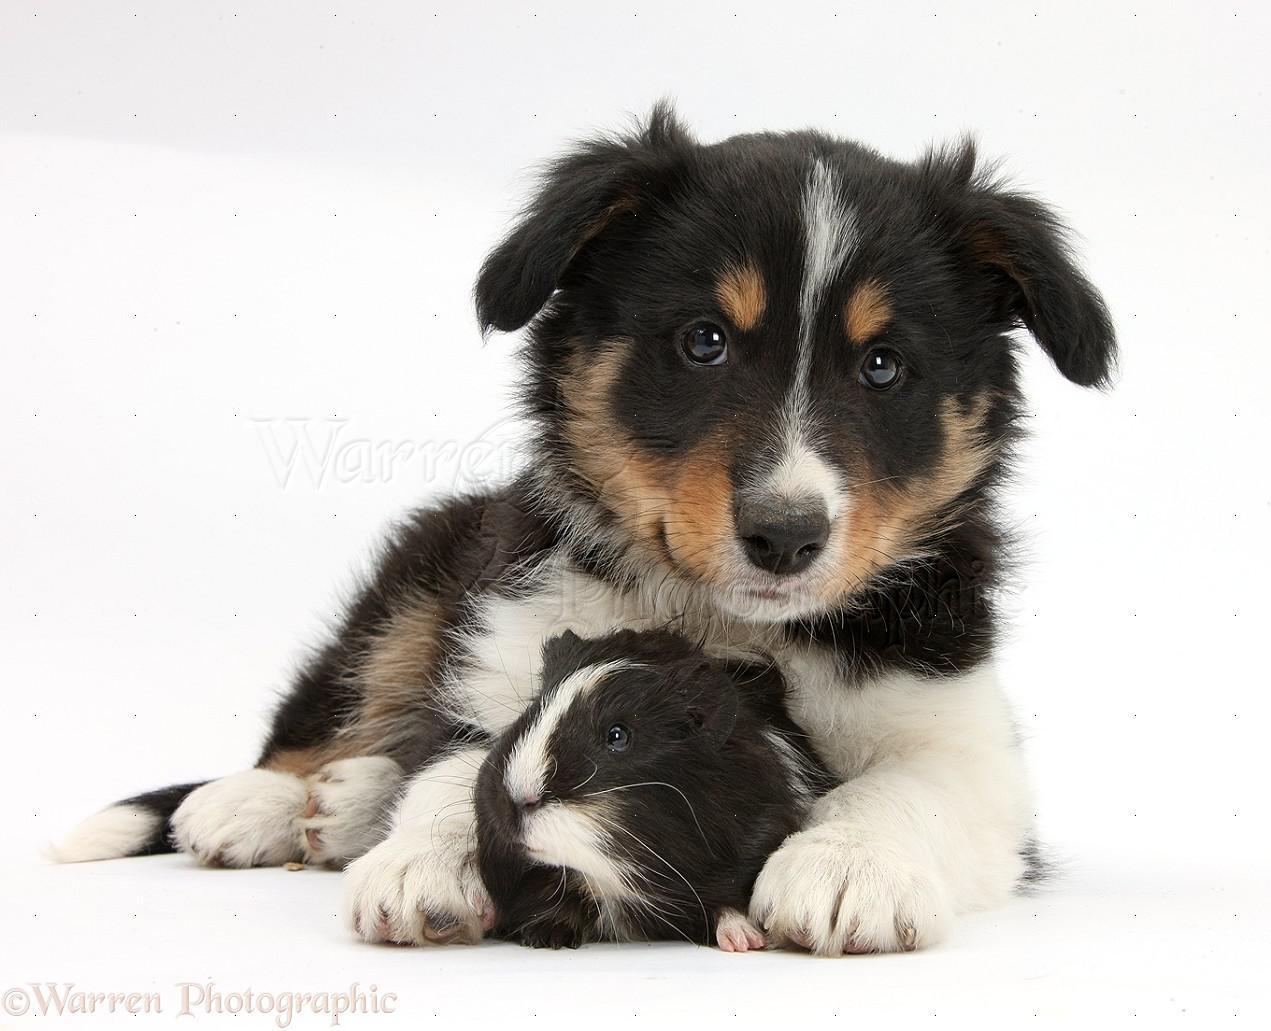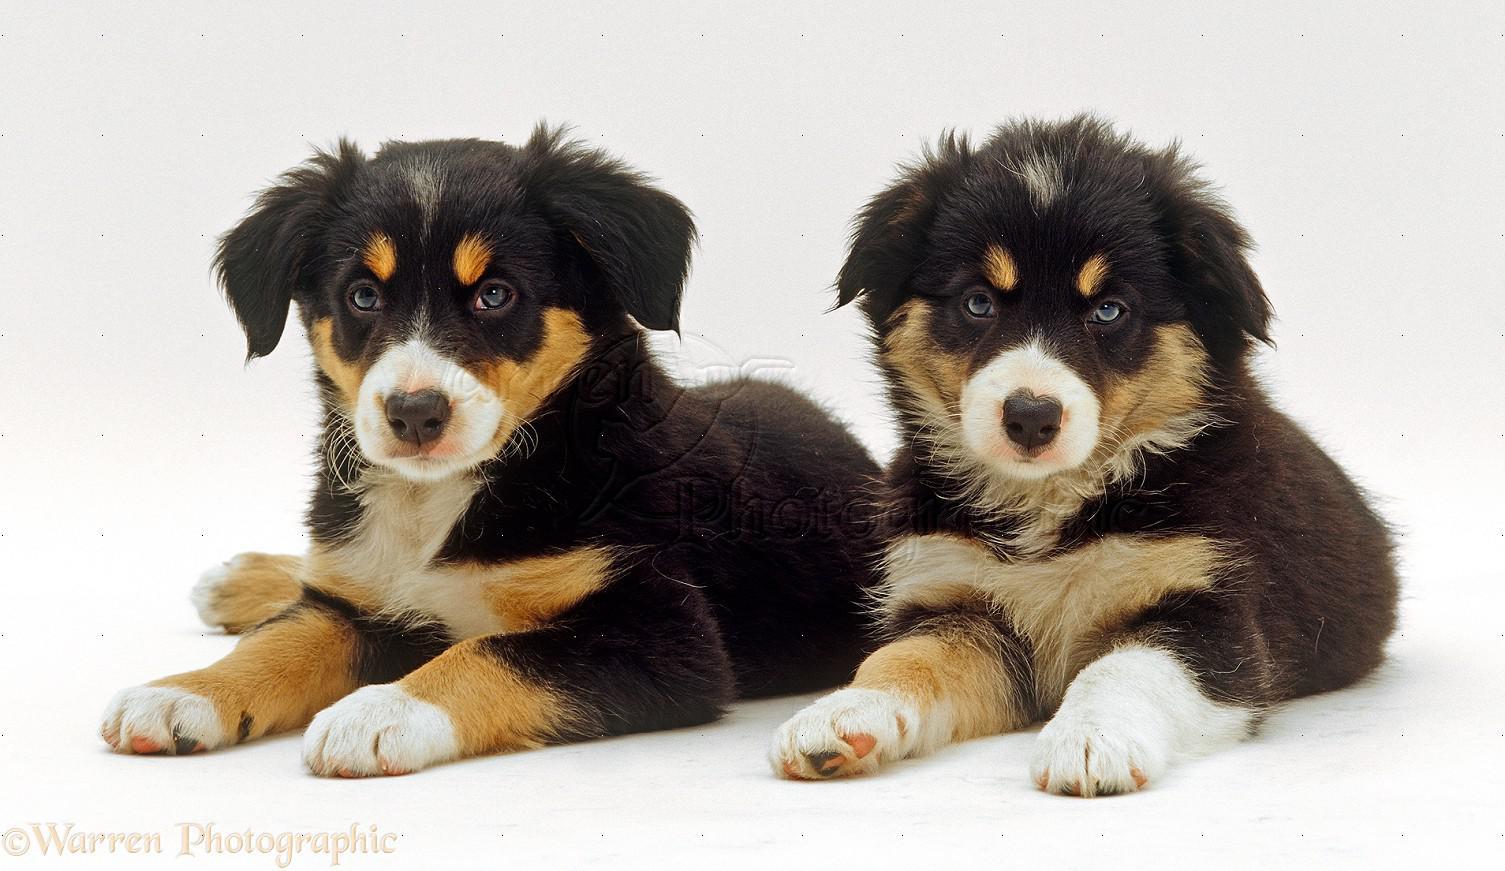The first image is the image on the left, the second image is the image on the right. Given the left and right images, does the statement "The right image contains exactly two dogs." hold true? Answer yes or no. Yes. The first image is the image on the left, the second image is the image on the right. For the images displayed, is the sentence "Each image features exactly two animals posed close together, and one image shows two dogs in a reclining position with front paws extended." factually correct? Answer yes or no. Yes. 